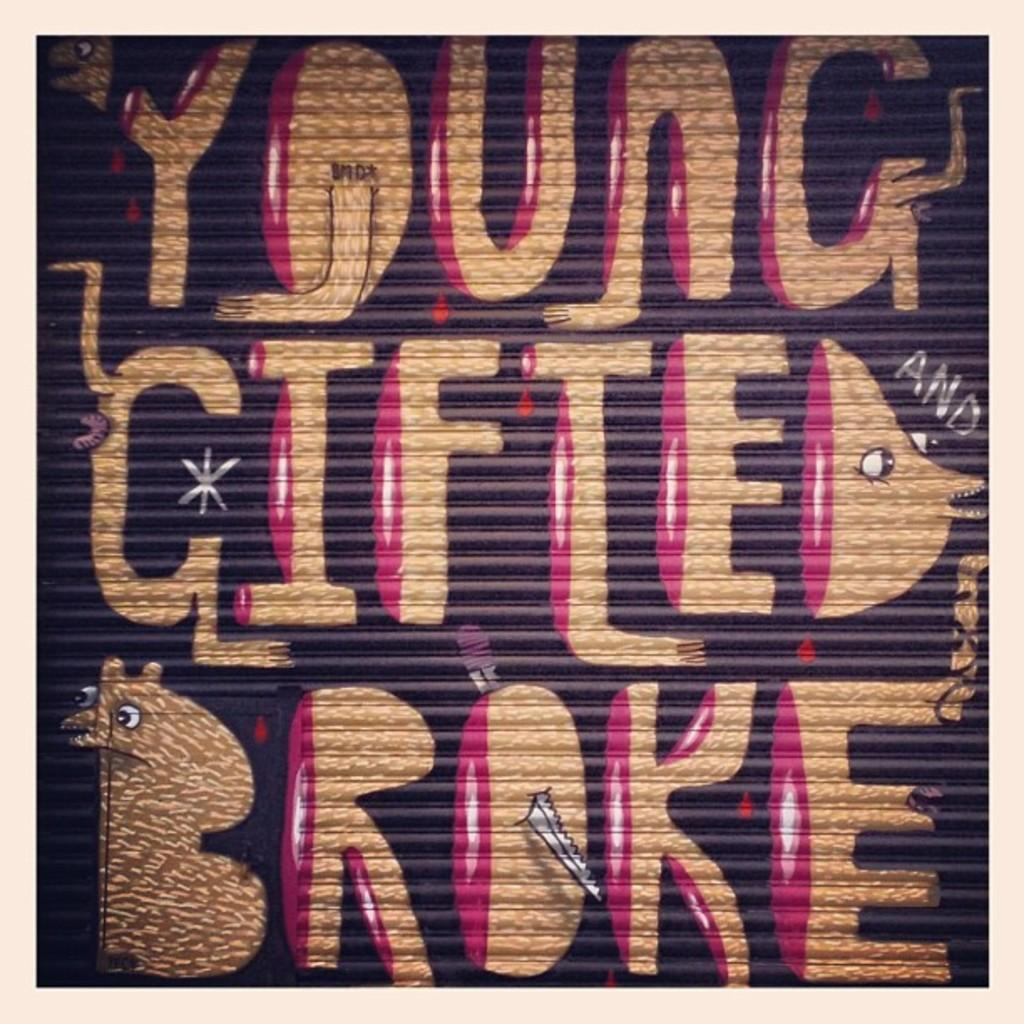Provide a one-sentence caption for the provided image. A graffiti saying "YOUNG GIFTED BROKE" is painted in gold and purple on the retractable door. 